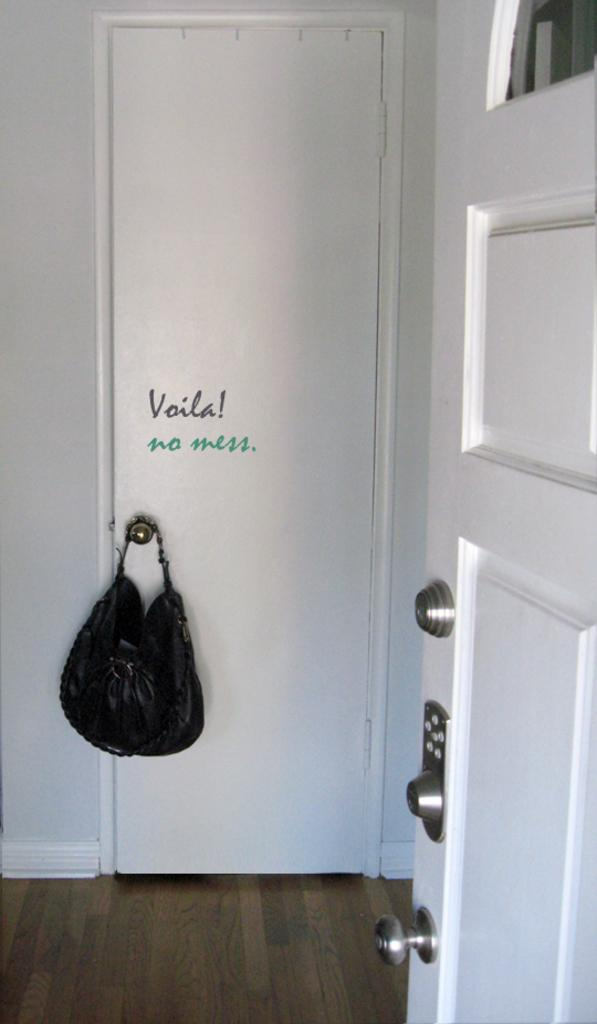What is the main object in the image? There is a door in the image. What is located near the door? There is a bag near the door. What can be seen beneath the door and bag? The floor is visible in the image. What type of silk material is draped over the door in the image? There is no silk material present in the image; it only features a door and a bag. 